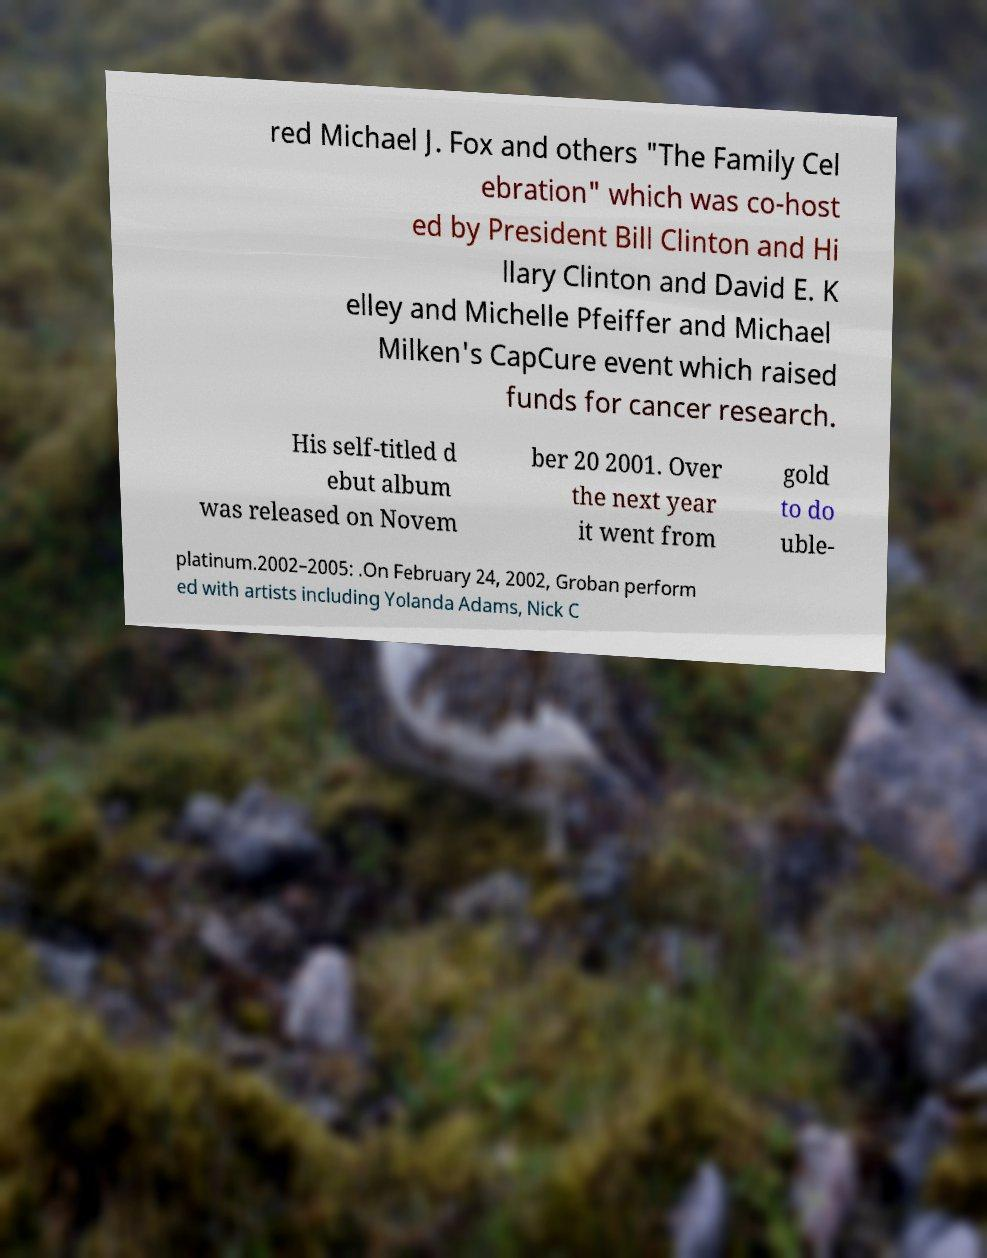Could you extract and type out the text from this image? red Michael J. Fox and others "The Family Cel ebration" which was co-host ed by President Bill Clinton and Hi llary Clinton and David E. K elley and Michelle Pfeiffer and Michael Milken's CapCure event which raised funds for cancer research. His self-titled d ebut album was released on Novem ber 20 2001. Over the next year it went from gold to do uble- platinum.2002–2005: .On February 24, 2002, Groban perform ed with artists including Yolanda Adams, Nick C 